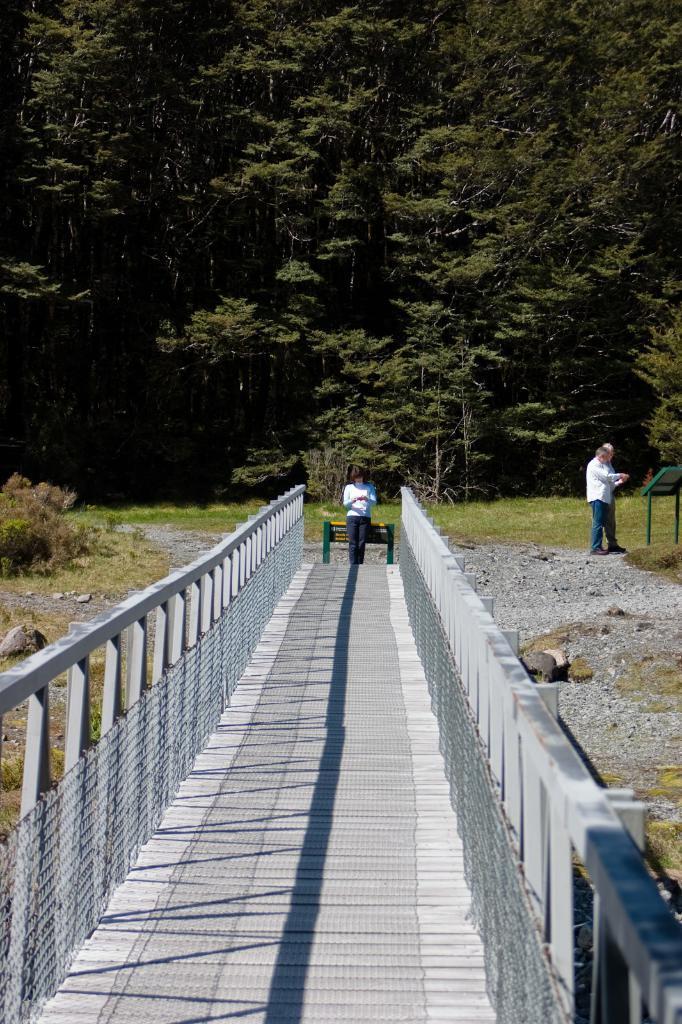Can you describe this image briefly? In this image I can see two persons standing, they are wearing white shirt, blue pant. Background I can see trees in green color. 